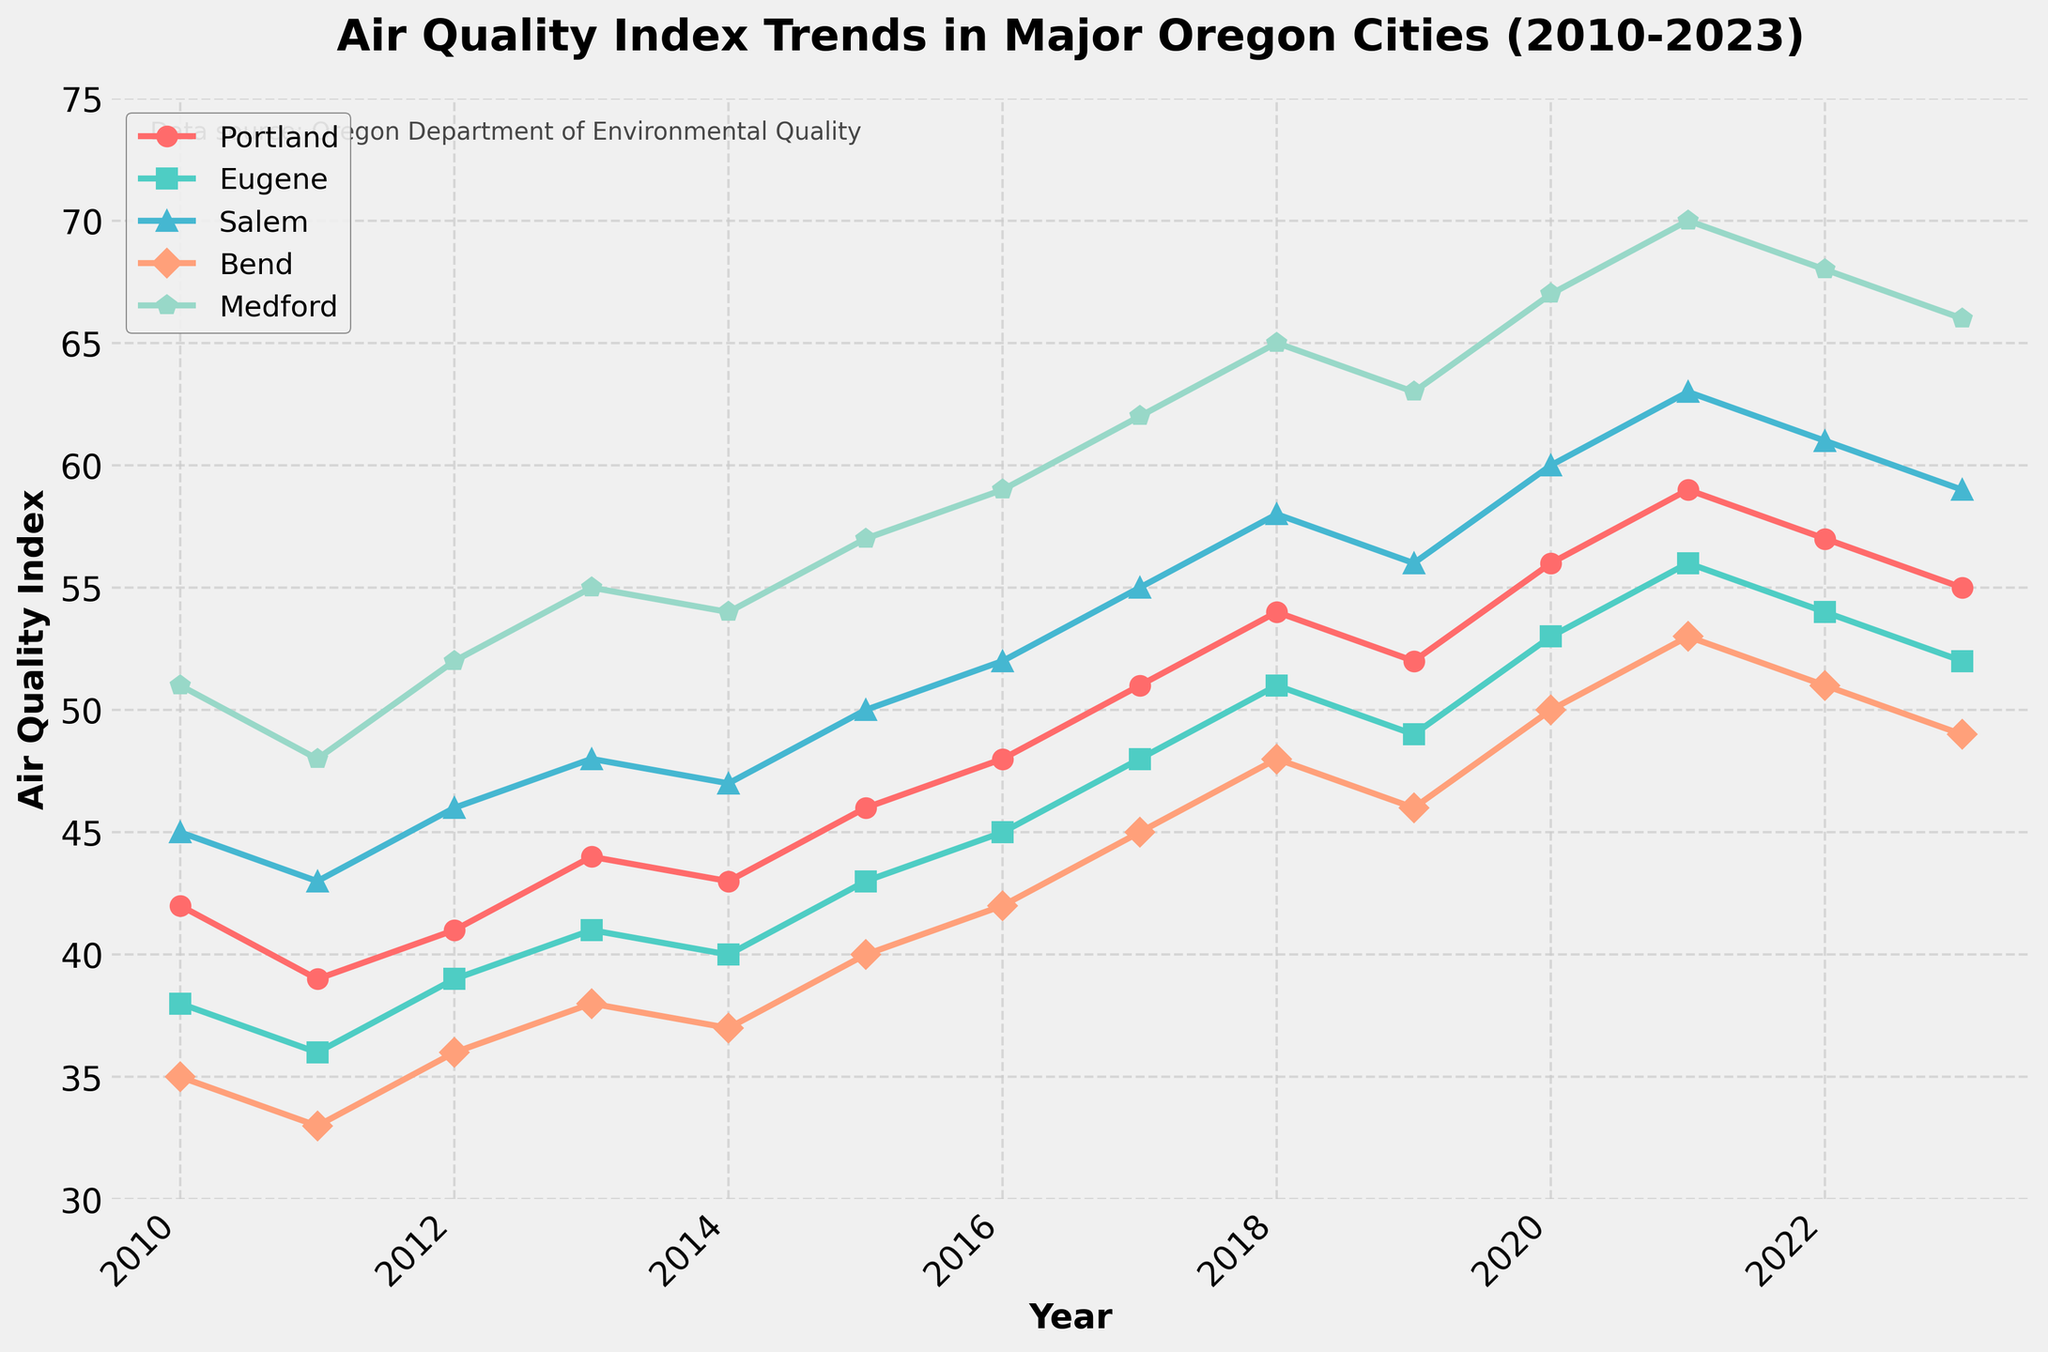What's the overall trend in air quality indices for Portland from 2010 to 2023? Looking closely at the line representing Portland, it starts at an AQI of 42 in 2010 and increases to 55 in 2023. This indicates a gradual increase in the air quality index over the years.
Answer: Increasing Which city had the highest Air Quality Index in 2023? Checking the air quality indices for each city in 2023, Medford has the highest value at 66.
Answer: Medford Which two cities had the closest Air Quality Index values in 2020, and what were those values? Comparing the AQIs for 2020, Portland had 56 and Eugene had 53, making them the closest values among the cities in that year.
Answer: Portland: 56, Eugene: 53 What's the difference in Air Quality Index between Bend and Salem in 2015? Bend’s AQI in 2015 is 40 and Salem’s AQI is 50. The difference is 50 - 40.
Answer: 10 By how much did the Air Quality Index increase for Bend from 2010 to 2023? Bend's AQI increases from 35 in 2010 to 49 in 2023. Here, 49 - 35 gives the increase.
Answer: 14 Which city experienced the largest increase in Air Quality Index from 2010 to 2023? Reviewing the AQI values, Medford had 51 in 2010 and 66 in 2023, resulting in an increase of 15, which is greater than the increases in the other cities.
Answer: Medford On average, how much did the Air Quality Index change per year for Eugene from 2010 to 2023? Eugene's AQI increased from 38 in 2010 to 52 in 2023. The difference is 52 - 38 = 14, and dividing by the 13-year period, 14 / 13.
Answer: Approx. 1.08 per year What can be inferred from the trend of AQI for Medford between 2018 and 2023? From the data, Medford's AQI starts at 65 in 2018 and ends slightly higher at 66 in 2023, showing a very mild increase.
Answer: Mild increase 